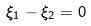<formula> <loc_0><loc_0><loc_500><loc_500>\xi _ { 1 } - \xi _ { 2 } = 0</formula> 